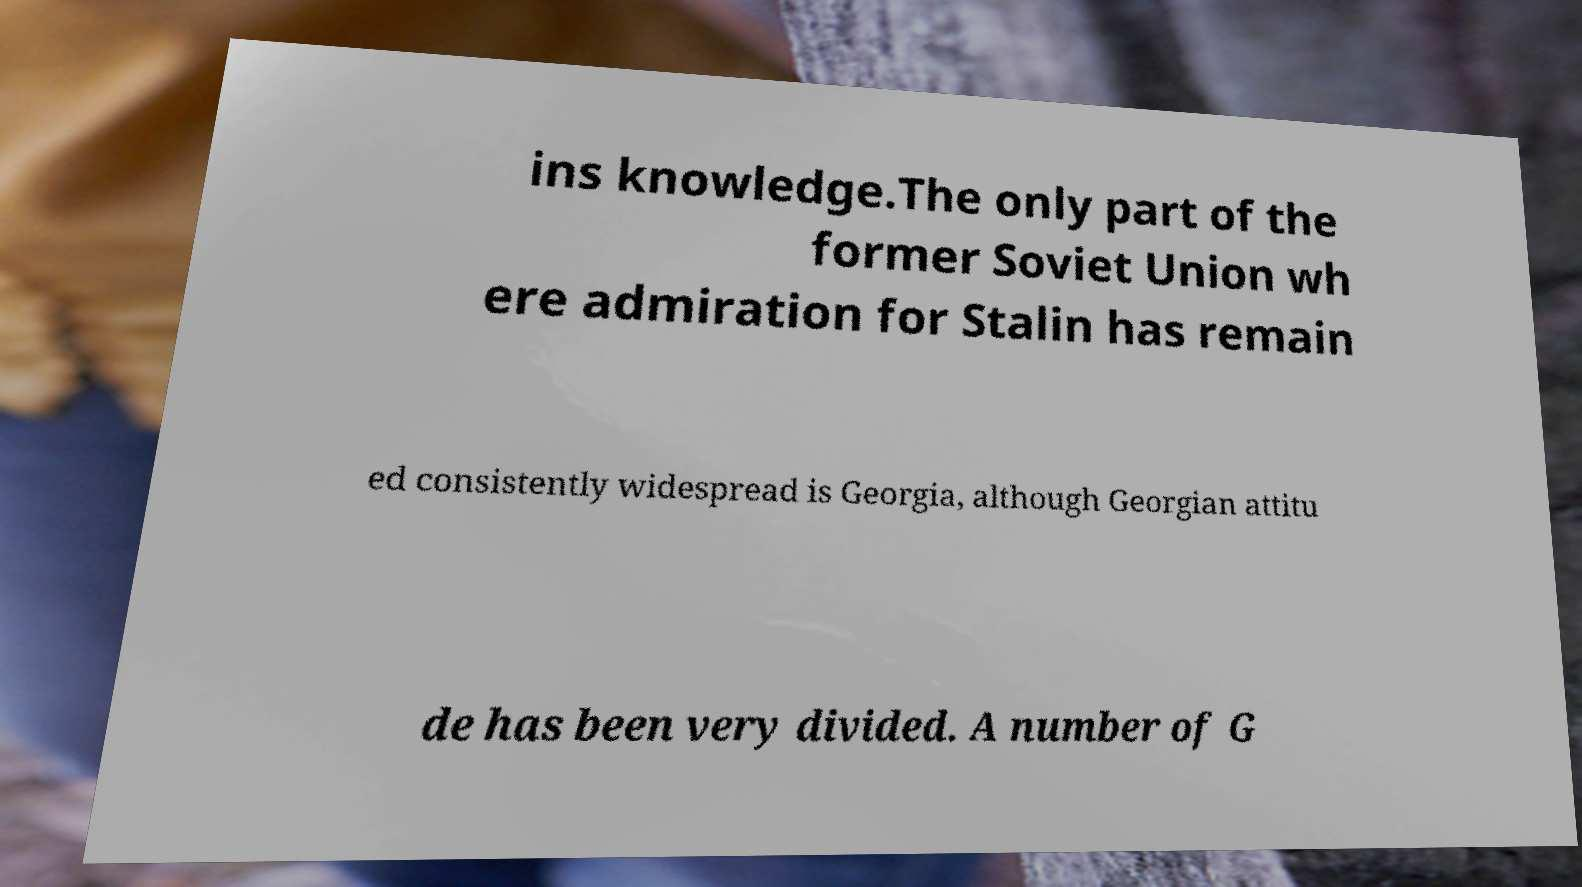There's text embedded in this image that I need extracted. Can you transcribe it verbatim? ins knowledge.The only part of the former Soviet Union wh ere admiration for Stalin has remain ed consistently widespread is Georgia, although Georgian attitu de has been very divided. A number of G 